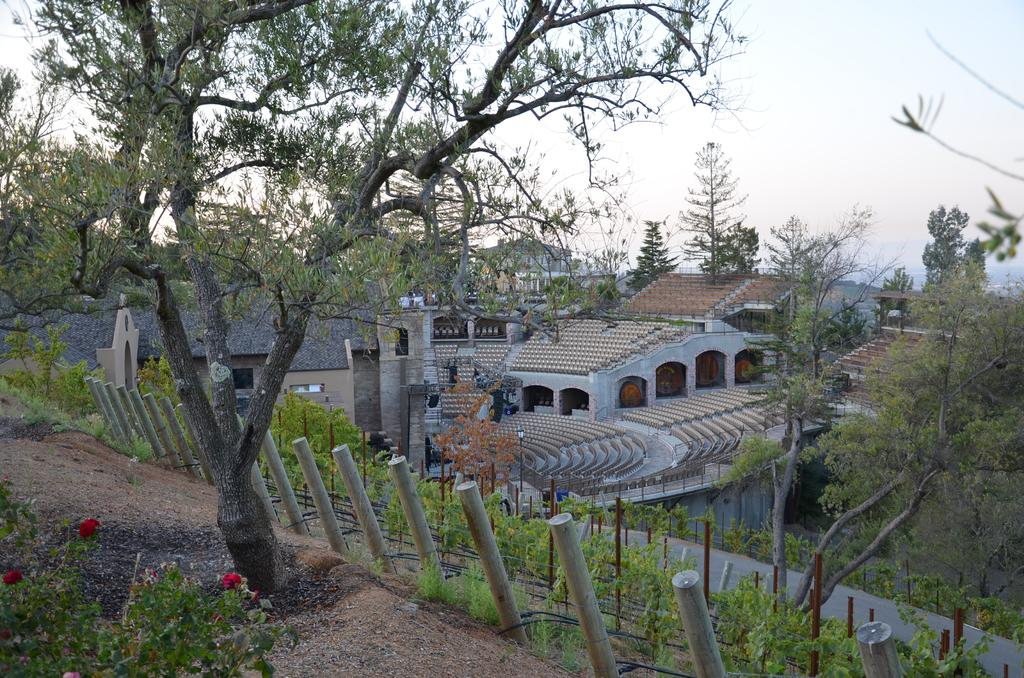What is the main structure in the picture? There is a stadium in the picture. What can be observed about the seating arrangement in the stadium? There are empty chairs in the stadium. What type of natural elements can be seen in the picture? Trees and plants are visible in the picture. What else is present in the picture besides the stadium? There are buildings and the sky is clear in the picture. How many sheep are grazing in the stadium in the picture? There are no sheep present in the picture; the image features a stadium with empty chairs. What effect does the morning light have on the stadium in the picture? The provided facts do not mention the time of day or the presence of morning light in the image. 